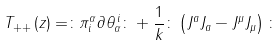<formula> <loc_0><loc_0><loc_500><loc_500>T _ { + + } \left ( z \right ) = \colon \pi _ { i } ^ { \alpha } \partial \theta _ { \alpha } ^ { \, i } \colon + \frac { 1 } { k } \colon \left ( J ^ { a } J _ { a } - J ^ { \mu } J _ { \mu } \right ) \colon</formula> 